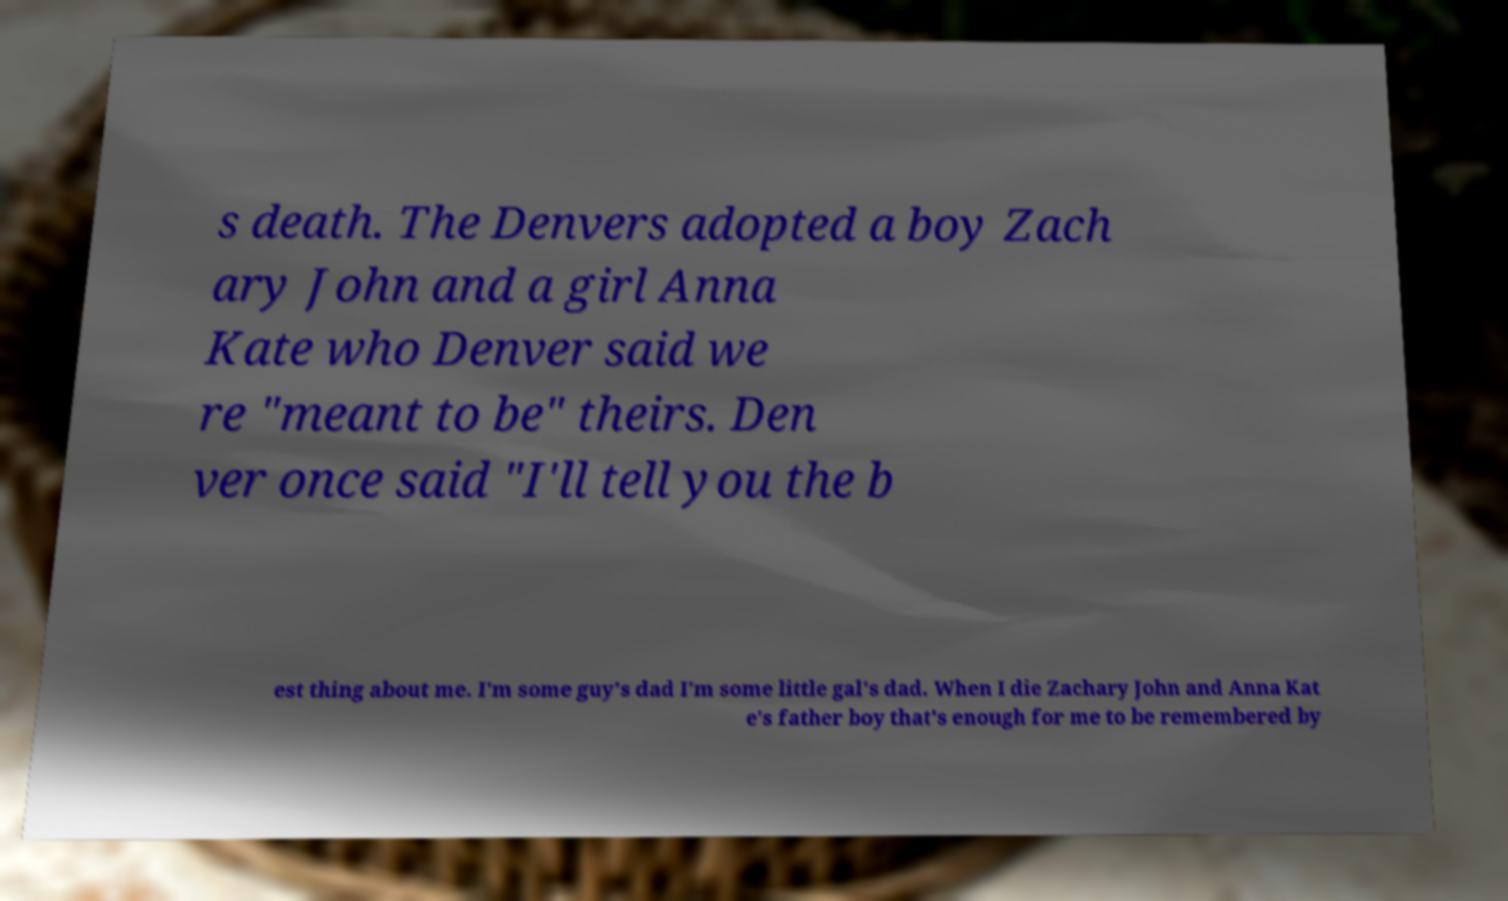Can you accurately transcribe the text from the provided image for me? s death. The Denvers adopted a boy Zach ary John and a girl Anna Kate who Denver said we re "meant to be" theirs. Den ver once said "I'll tell you the b est thing about me. I'm some guy's dad I'm some little gal's dad. When I die Zachary John and Anna Kat e's father boy that's enough for me to be remembered by 